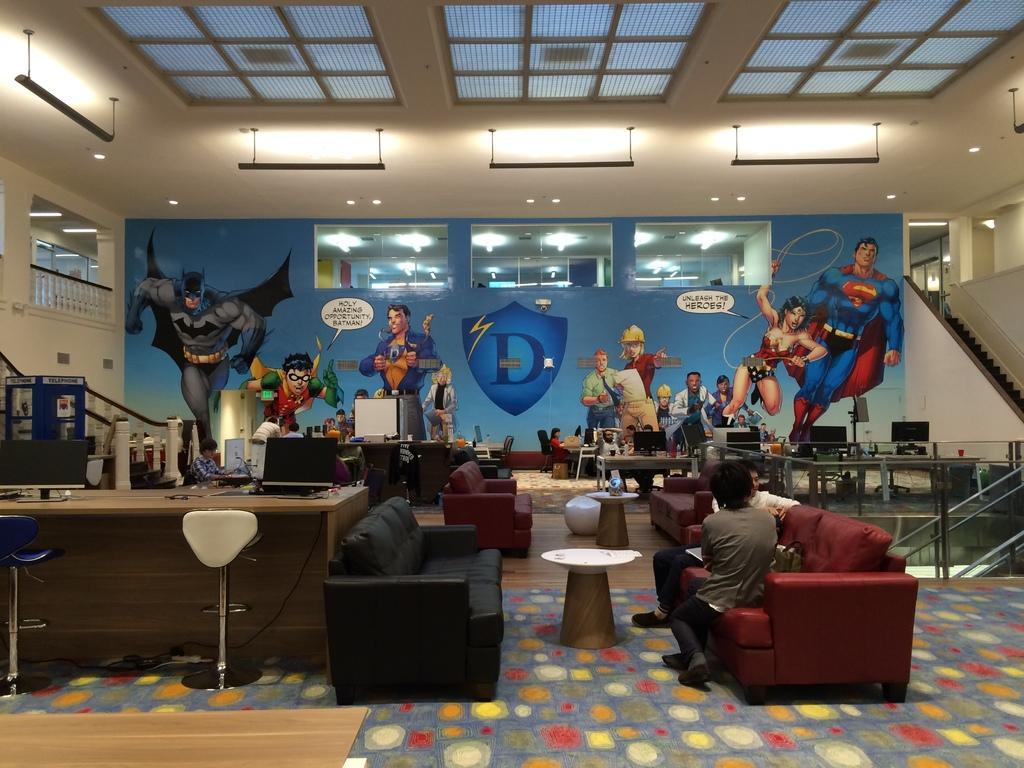How would you summarize this image in a sentence or two? In this image I see a room and there are lot of sofas and tables and there are lot of computers too and there are few people. In the background I see the wall and their fictional characters on it and there are lights. 